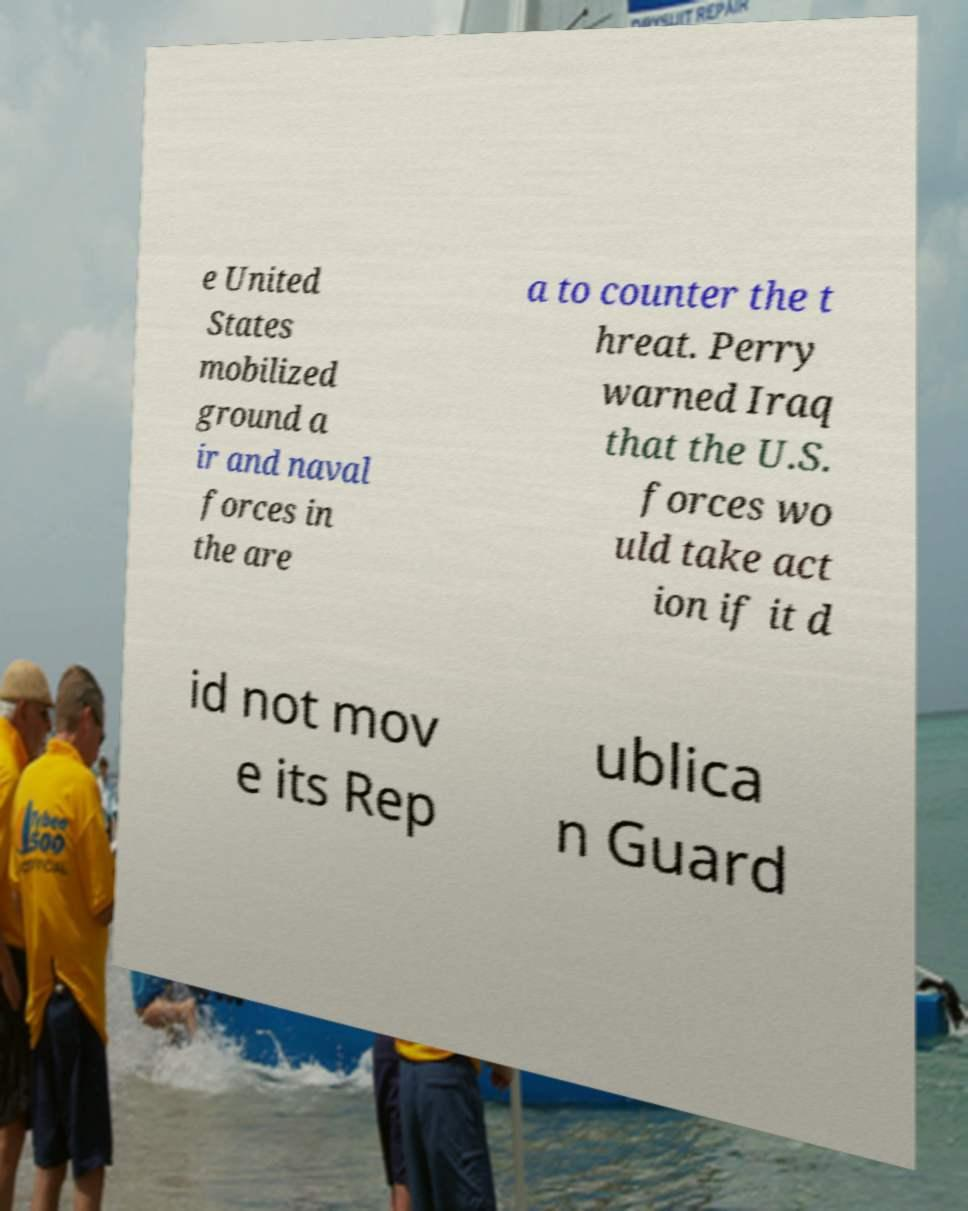Could you assist in decoding the text presented in this image and type it out clearly? e United States mobilized ground a ir and naval forces in the are a to counter the t hreat. Perry warned Iraq that the U.S. forces wo uld take act ion if it d id not mov e its Rep ublica n Guard 